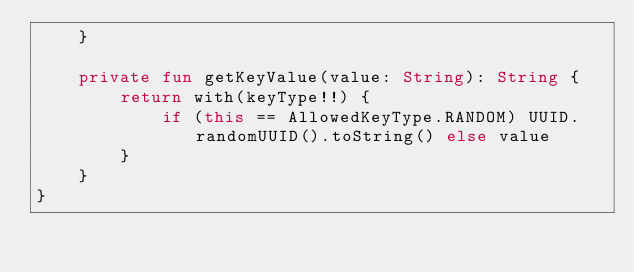Convert code to text. <code><loc_0><loc_0><loc_500><loc_500><_Kotlin_>    }

    private fun getKeyValue(value: String): String {
        return with(keyType!!) {
            if (this == AllowedKeyType.RANDOM) UUID.randomUUID().toString() else value
        }
    }
}</code> 